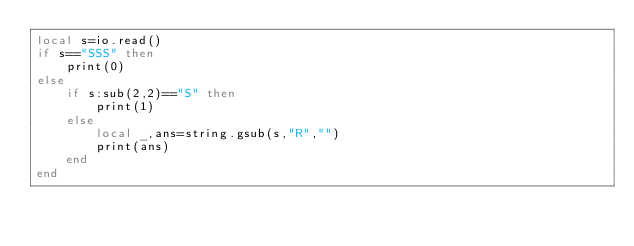<code> <loc_0><loc_0><loc_500><loc_500><_Lua_>local s=io.read()
if s=="SSS" then
    print(0)
else
    if s:sub(2,2)=="S" then
        print(1)
    else
        local _,ans=string.gsub(s,"R","")
        print(ans)
    end
end</code> 